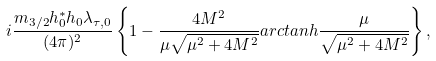Convert formula to latex. <formula><loc_0><loc_0><loc_500><loc_500>i \frac { m _ { 3 / 2 } h _ { 0 } ^ { * } h _ { 0 } \lambda _ { \tau , 0 } } { ( 4 \pi ) ^ { 2 } } \left \{ 1 - \frac { 4 M ^ { 2 } } { \mu \sqrt { \mu ^ { 2 } + 4 M ^ { 2 } } } a r c t a n h \frac { \mu } { \sqrt { \mu ^ { 2 } + 4 M ^ { 2 } } } \right \} ,</formula> 